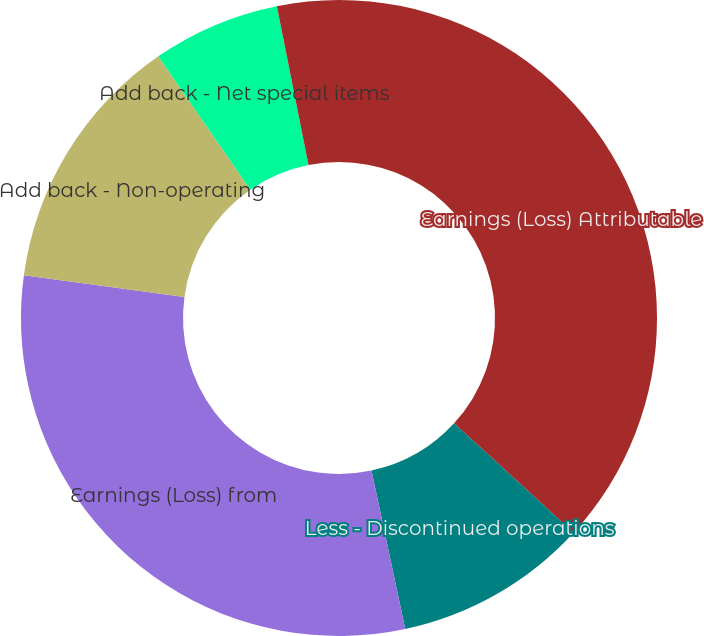<chart> <loc_0><loc_0><loc_500><loc_500><pie_chart><fcel>Earnings (Loss) Attributable<fcel>Less - Discontinued operations<fcel>Earnings (Loss) from<fcel>Add back - Non-operating<fcel>Add back - Net special items<fcel>Income tax effect -<nl><fcel>36.8%<fcel>9.86%<fcel>30.49%<fcel>13.23%<fcel>6.49%<fcel>3.13%<nl></chart> 